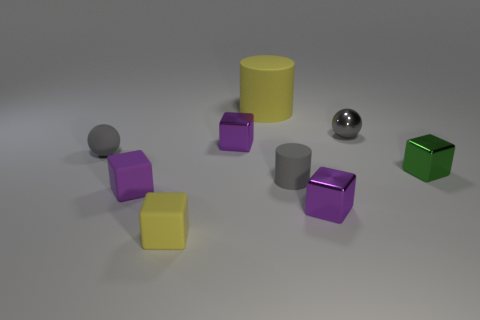Subtract all brown cylinders. How many purple blocks are left? 3 Add 1 large yellow cylinders. How many objects exist? 10 Subtract all blocks. How many objects are left? 4 Add 4 tiny green blocks. How many tiny green blocks exist? 5 Subtract 0 blue cylinders. How many objects are left? 9 Subtract all tiny gray shiny objects. Subtract all small things. How many objects are left? 0 Add 8 green metallic things. How many green metallic things are left? 9 